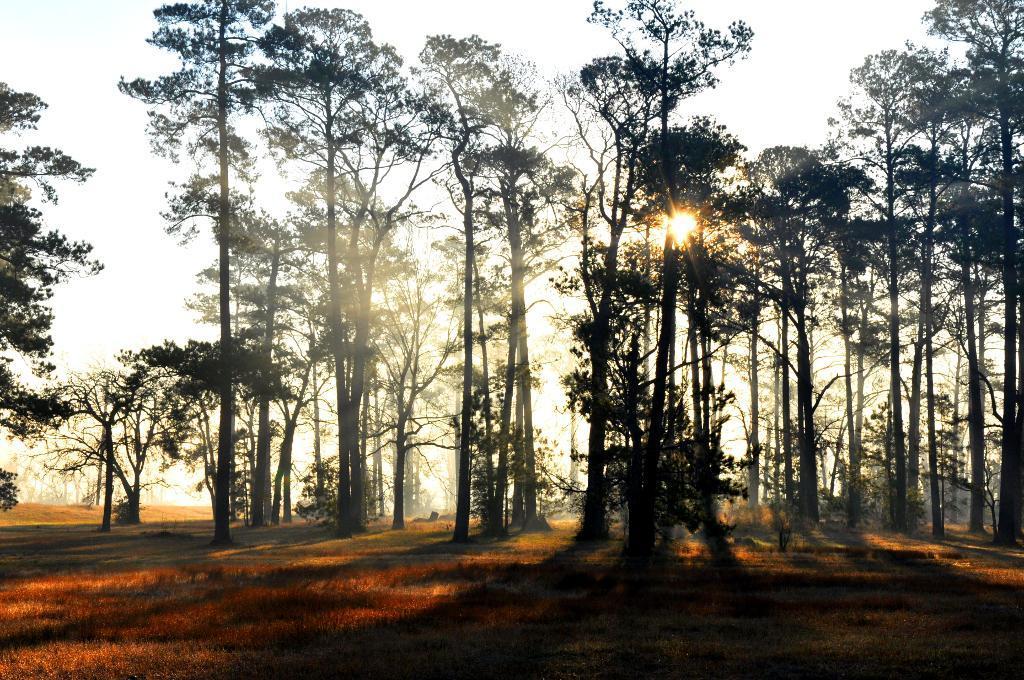Please provide a concise description of this image. In this image we can see trees, grass, sun and sky. 